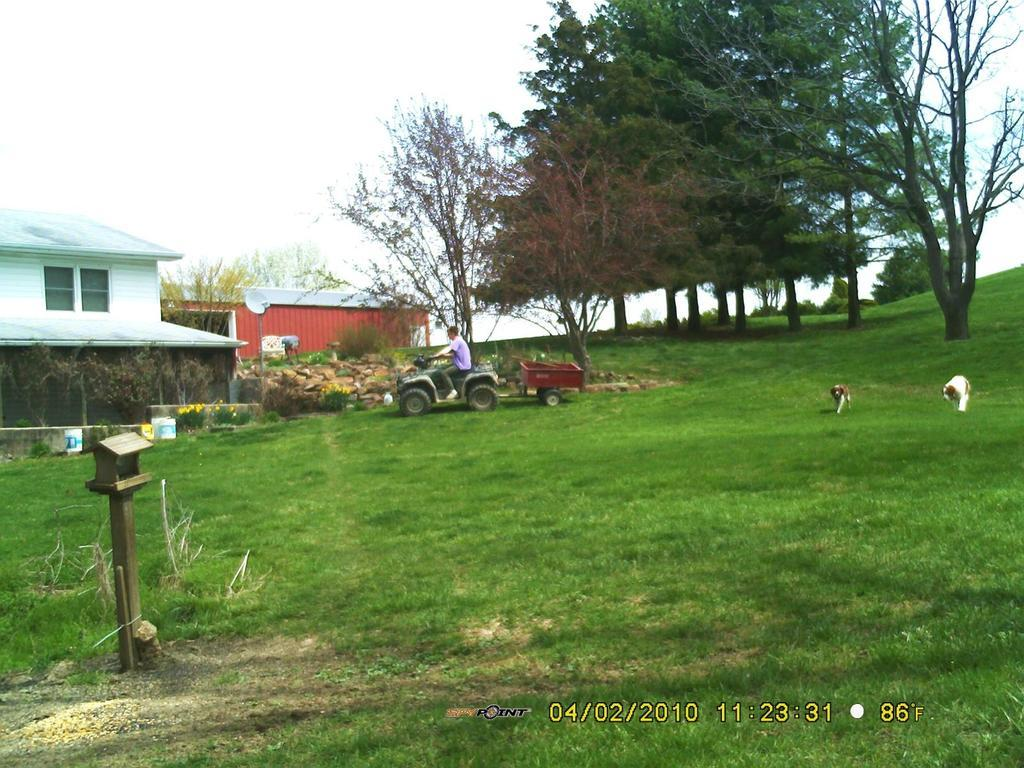What is the man doing in the image? The man is seated on a vehicle in the image. What animals can be seen on the grass in the image? There are dogs on the grass in the image. What can be seen in the distance in the image? Trees and houses are visible in the background of the image. What type of verse is being recited by the chicken in the image? There is no chicken present in the image, so it is not possible to determine if a verse is being recited. 